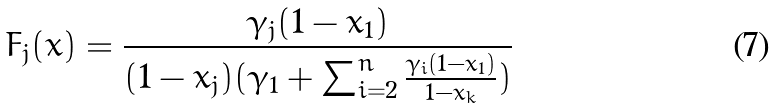<formula> <loc_0><loc_0><loc_500><loc_500>F _ { j } ( x ) = \frac { \gamma _ { j } ( 1 - x _ { 1 } ) } { ( 1 - x _ { j } ) ( \gamma _ { 1 } + \sum _ { i = 2 } ^ { n } \frac { \gamma _ { i } ( 1 - x _ { 1 } ) } { 1 - x _ { k } } ) }</formula> 